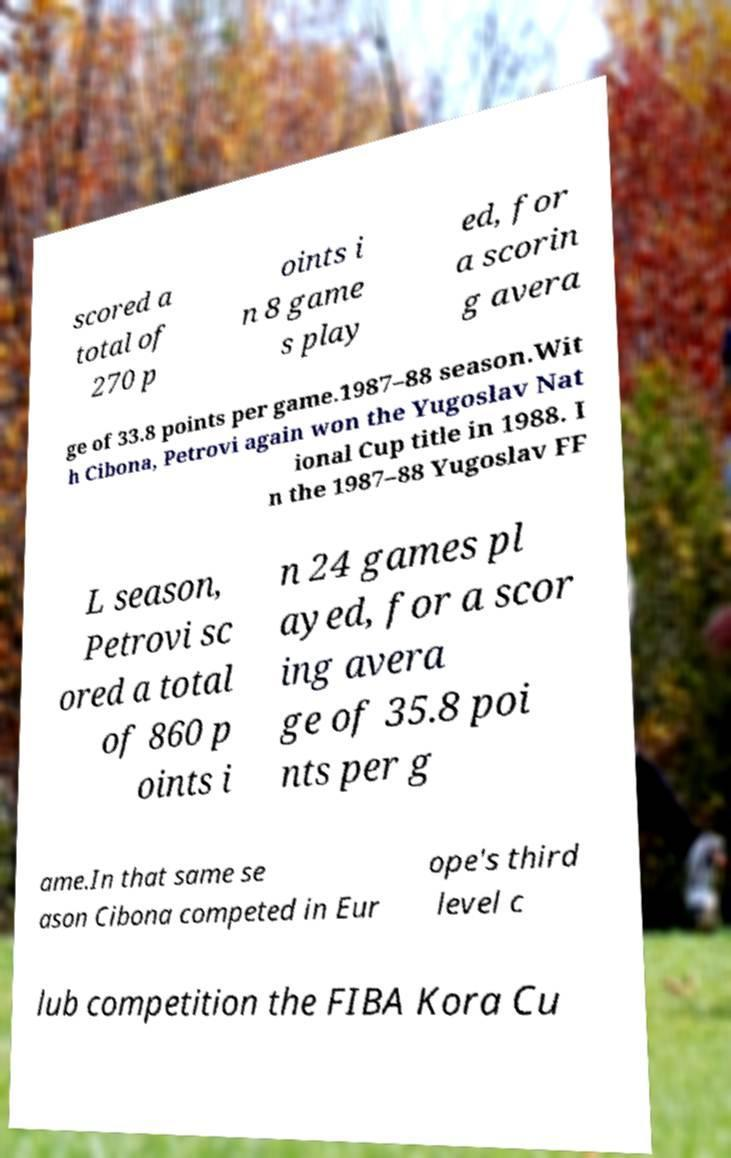Could you extract and type out the text from this image? scored a total of 270 p oints i n 8 game s play ed, for a scorin g avera ge of 33.8 points per game.1987–88 season.Wit h Cibona, Petrovi again won the Yugoslav Nat ional Cup title in 1988. I n the 1987–88 Yugoslav FF L season, Petrovi sc ored a total of 860 p oints i n 24 games pl ayed, for a scor ing avera ge of 35.8 poi nts per g ame.In that same se ason Cibona competed in Eur ope's third level c lub competition the FIBA Kora Cu 